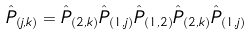Convert formula to latex. <formula><loc_0><loc_0><loc_500><loc_500>\hat { P } _ { ( j , k ) } = \hat { P } _ { ( 2 , k ) } \hat { P } _ { ( 1 , j ) } \hat { P } _ { ( 1 , 2 ) } \hat { P } _ { ( 2 , k ) } \hat { P } _ { ( 1 , j ) }</formula> 